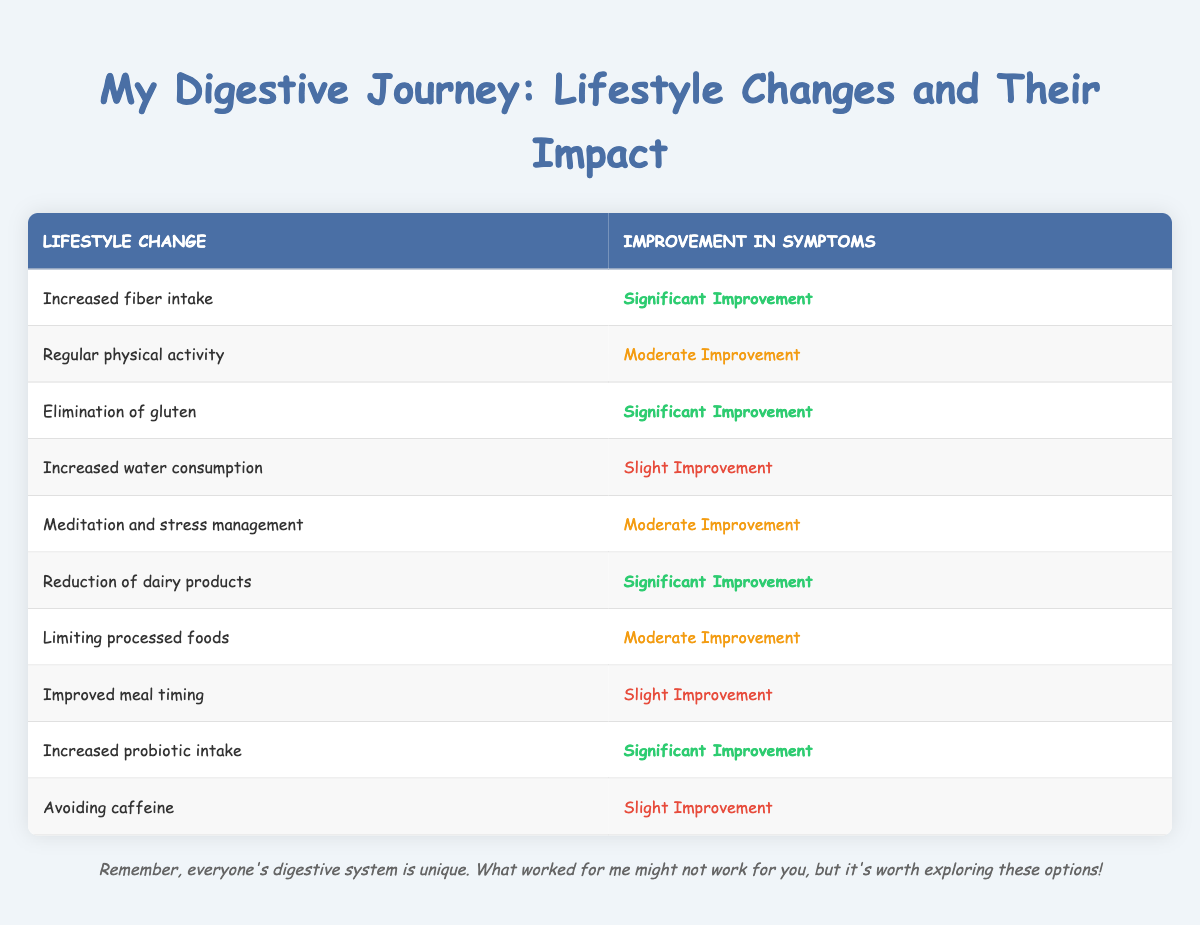What is one lifestyle change that resulted in significant improvement? The table shows multiple lifestyle changes that led to significant improvement in symptoms. For instance, "Increased fiber intake" and "Elimination of gluten" both resulted in significant improvement.
Answer: Increased fiber intake How many lifestyle changes show slight improvement in symptoms? By reviewing the table, "Increased water consumption," "Improved meal timing," and "Avoiding caffeine" are the three changes that resulted in slight improvement. Thus, the total number is three.
Answer: 3 Which lifestyle change has the highest level of improvement according to the table? Looking at the improvements, "Increased fiber intake," "Elimination of gluten," "Reduction of dairy products," and "Increased probiotic intake" are all labeled as significant improvement. There are four such instances, indicating that they represent the highest level of improvement.
Answer: 4 instances Do more lifestyle changes lead to significant improvement or slight improvement in symptoms? The table indicates that there are 4 lifestyle changes that result in significant improvement ("Increased fiber intake," "Elimination of gluten," "Reduction of dairy products," "Increased probiotic intake") and only 3 lifestyle changes that show slight improvement. Therefore, more changes lead to significant improvement.
Answer: Significant improvement If someone made all the lifestyle changes listed, what would be the range of improvement in their symptoms? The improvements in symptoms range from slight to significant. The least improvement is slight, while the best improvement is significant, indicating a full range exists.
Answer: Slight to significant 